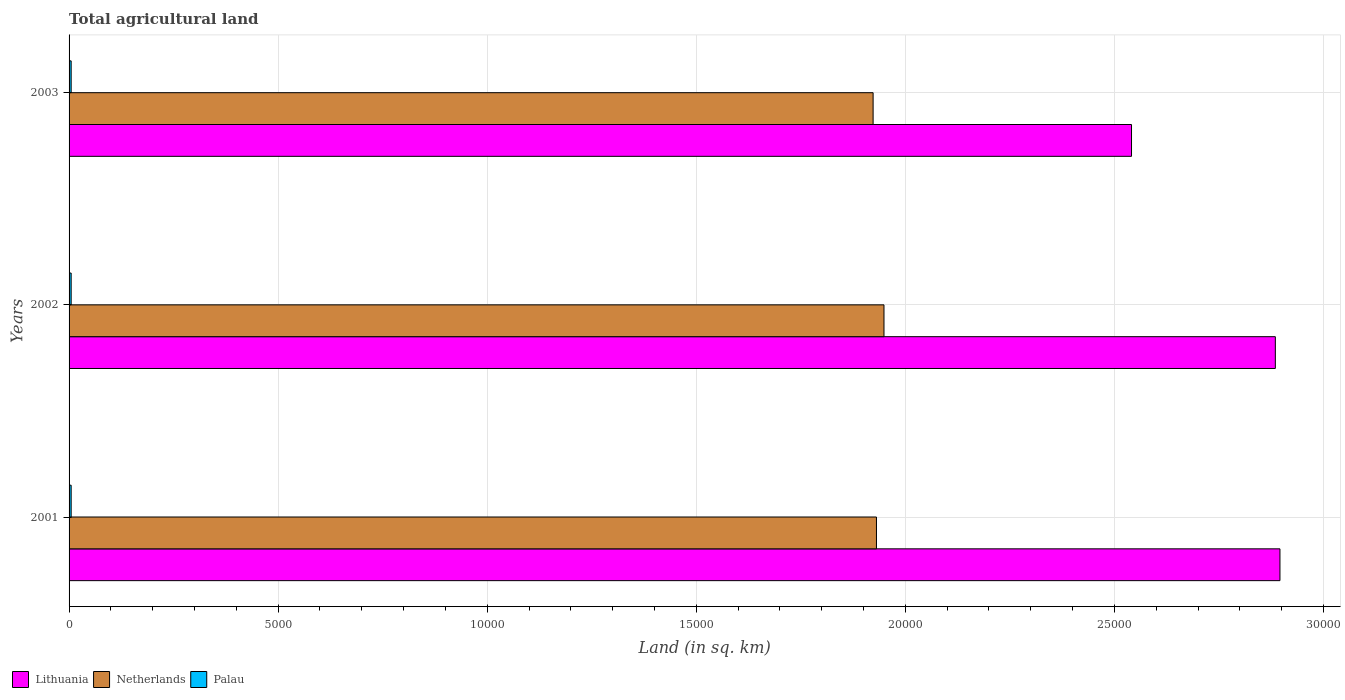Are the number of bars per tick equal to the number of legend labels?
Offer a very short reply. Yes. What is the total agricultural land in Palau in 2003?
Give a very brief answer. 50. Across all years, what is the maximum total agricultural land in Netherlands?
Provide a succinct answer. 1.95e+04. In which year was the total agricultural land in Palau maximum?
Provide a succinct answer. 2001. In which year was the total agricultural land in Palau minimum?
Offer a terse response. 2001. What is the total total agricultural land in Lithuania in the graph?
Your response must be concise. 8.32e+04. What is the difference between the total agricultural land in Netherlands in 2001 and that in 2002?
Offer a very short reply. -180. What is the difference between the total agricultural land in Palau in 2001 and the total agricultural land in Netherlands in 2003?
Keep it short and to the point. -1.92e+04. What is the average total agricultural land in Netherlands per year?
Offer a very short reply. 1.93e+04. In the year 2003, what is the difference between the total agricultural land in Netherlands and total agricultural land in Lithuania?
Make the answer very short. -6180. What is the ratio of the total agricultural land in Netherlands in 2002 to that in 2003?
Your answer should be very brief. 1.01. What is the difference between the highest and the second highest total agricultural land in Lithuania?
Ensure brevity in your answer.  110. What is the difference between the highest and the lowest total agricultural land in Lithuania?
Give a very brief answer. 3550. In how many years, is the total agricultural land in Netherlands greater than the average total agricultural land in Netherlands taken over all years?
Provide a short and direct response. 1. What does the 2nd bar from the top in 2001 represents?
Provide a short and direct response. Netherlands. What does the 3rd bar from the bottom in 2001 represents?
Your answer should be very brief. Palau. Is it the case that in every year, the sum of the total agricultural land in Netherlands and total agricultural land in Palau is greater than the total agricultural land in Lithuania?
Provide a short and direct response. No. How many bars are there?
Your answer should be compact. 9. Are all the bars in the graph horizontal?
Provide a succinct answer. Yes. What is the difference between two consecutive major ticks on the X-axis?
Your response must be concise. 5000. Are the values on the major ticks of X-axis written in scientific E-notation?
Give a very brief answer. No. Does the graph contain any zero values?
Keep it short and to the point. No. Does the graph contain grids?
Provide a short and direct response. Yes. Where does the legend appear in the graph?
Your answer should be very brief. Bottom left. How are the legend labels stacked?
Your response must be concise. Horizontal. What is the title of the graph?
Keep it short and to the point. Total agricultural land. What is the label or title of the X-axis?
Make the answer very short. Land (in sq. km). What is the label or title of the Y-axis?
Make the answer very short. Years. What is the Land (in sq. km) in Lithuania in 2001?
Provide a short and direct response. 2.90e+04. What is the Land (in sq. km) in Netherlands in 2001?
Provide a succinct answer. 1.93e+04. What is the Land (in sq. km) in Palau in 2001?
Your answer should be very brief. 50. What is the Land (in sq. km) of Lithuania in 2002?
Your answer should be very brief. 2.88e+04. What is the Land (in sq. km) in Netherlands in 2002?
Keep it short and to the point. 1.95e+04. What is the Land (in sq. km) of Palau in 2002?
Keep it short and to the point. 50. What is the Land (in sq. km) in Lithuania in 2003?
Your answer should be very brief. 2.54e+04. What is the Land (in sq. km) of Netherlands in 2003?
Ensure brevity in your answer.  1.92e+04. Across all years, what is the maximum Land (in sq. km) in Lithuania?
Ensure brevity in your answer.  2.90e+04. Across all years, what is the maximum Land (in sq. km) of Netherlands?
Offer a terse response. 1.95e+04. Across all years, what is the minimum Land (in sq. km) in Lithuania?
Provide a succinct answer. 2.54e+04. Across all years, what is the minimum Land (in sq. km) in Netherlands?
Your answer should be compact. 1.92e+04. What is the total Land (in sq. km) of Lithuania in the graph?
Make the answer very short. 8.32e+04. What is the total Land (in sq. km) in Netherlands in the graph?
Offer a very short reply. 5.80e+04. What is the total Land (in sq. km) in Palau in the graph?
Offer a very short reply. 150. What is the difference between the Land (in sq. km) in Lithuania in 2001 and that in 2002?
Give a very brief answer. 110. What is the difference between the Land (in sq. km) of Netherlands in 2001 and that in 2002?
Keep it short and to the point. -180. What is the difference between the Land (in sq. km) in Palau in 2001 and that in 2002?
Your answer should be very brief. 0. What is the difference between the Land (in sq. km) of Lithuania in 2001 and that in 2003?
Your answer should be compact. 3550. What is the difference between the Land (in sq. km) of Palau in 2001 and that in 2003?
Offer a very short reply. 0. What is the difference between the Land (in sq. km) of Lithuania in 2002 and that in 2003?
Provide a succinct answer. 3440. What is the difference between the Land (in sq. km) in Netherlands in 2002 and that in 2003?
Keep it short and to the point. 260. What is the difference between the Land (in sq. km) of Palau in 2002 and that in 2003?
Provide a short and direct response. 0. What is the difference between the Land (in sq. km) in Lithuania in 2001 and the Land (in sq. km) in Netherlands in 2002?
Keep it short and to the point. 9470. What is the difference between the Land (in sq. km) of Lithuania in 2001 and the Land (in sq. km) of Palau in 2002?
Ensure brevity in your answer.  2.89e+04. What is the difference between the Land (in sq. km) in Netherlands in 2001 and the Land (in sq. km) in Palau in 2002?
Offer a terse response. 1.93e+04. What is the difference between the Land (in sq. km) of Lithuania in 2001 and the Land (in sq. km) of Netherlands in 2003?
Your answer should be very brief. 9730. What is the difference between the Land (in sq. km) in Lithuania in 2001 and the Land (in sq. km) in Palau in 2003?
Your answer should be very brief. 2.89e+04. What is the difference between the Land (in sq. km) in Netherlands in 2001 and the Land (in sq. km) in Palau in 2003?
Keep it short and to the point. 1.93e+04. What is the difference between the Land (in sq. km) of Lithuania in 2002 and the Land (in sq. km) of Netherlands in 2003?
Your answer should be compact. 9620. What is the difference between the Land (in sq. km) in Lithuania in 2002 and the Land (in sq. km) in Palau in 2003?
Give a very brief answer. 2.88e+04. What is the difference between the Land (in sq. km) of Netherlands in 2002 and the Land (in sq. km) of Palau in 2003?
Keep it short and to the point. 1.94e+04. What is the average Land (in sq. km) in Lithuania per year?
Your answer should be very brief. 2.77e+04. What is the average Land (in sq. km) in Netherlands per year?
Your response must be concise. 1.93e+04. In the year 2001, what is the difference between the Land (in sq. km) in Lithuania and Land (in sq. km) in Netherlands?
Provide a succinct answer. 9650. In the year 2001, what is the difference between the Land (in sq. km) of Lithuania and Land (in sq. km) of Palau?
Your answer should be very brief. 2.89e+04. In the year 2001, what is the difference between the Land (in sq. km) in Netherlands and Land (in sq. km) in Palau?
Give a very brief answer. 1.93e+04. In the year 2002, what is the difference between the Land (in sq. km) of Lithuania and Land (in sq. km) of Netherlands?
Your answer should be compact. 9360. In the year 2002, what is the difference between the Land (in sq. km) of Lithuania and Land (in sq. km) of Palau?
Offer a terse response. 2.88e+04. In the year 2002, what is the difference between the Land (in sq. km) in Netherlands and Land (in sq. km) in Palau?
Your answer should be very brief. 1.94e+04. In the year 2003, what is the difference between the Land (in sq. km) of Lithuania and Land (in sq. km) of Netherlands?
Your response must be concise. 6180. In the year 2003, what is the difference between the Land (in sq. km) in Lithuania and Land (in sq. km) in Palau?
Make the answer very short. 2.54e+04. In the year 2003, what is the difference between the Land (in sq. km) in Netherlands and Land (in sq. km) in Palau?
Your answer should be very brief. 1.92e+04. What is the ratio of the Land (in sq. km) in Lithuania in 2001 to that in 2002?
Your answer should be very brief. 1. What is the ratio of the Land (in sq. km) in Netherlands in 2001 to that in 2002?
Make the answer very short. 0.99. What is the ratio of the Land (in sq. km) in Lithuania in 2001 to that in 2003?
Ensure brevity in your answer.  1.14. What is the ratio of the Land (in sq. km) of Netherlands in 2001 to that in 2003?
Offer a terse response. 1. What is the ratio of the Land (in sq. km) in Palau in 2001 to that in 2003?
Make the answer very short. 1. What is the ratio of the Land (in sq. km) in Lithuania in 2002 to that in 2003?
Make the answer very short. 1.14. What is the ratio of the Land (in sq. km) of Netherlands in 2002 to that in 2003?
Keep it short and to the point. 1.01. What is the difference between the highest and the second highest Land (in sq. km) of Lithuania?
Your answer should be compact. 110. What is the difference between the highest and the second highest Land (in sq. km) in Netherlands?
Your answer should be very brief. 180. What is the difference between the highest and the lowest Land (in sq. km) of Lithuania?
Offer a terse response. 3550. What is the difference between the highest and the lowest Land (in sq. km) of Netherlands?
Your answer should be very brief. 260. 